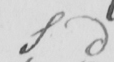Can you tell me what this handwritten text says? S d 